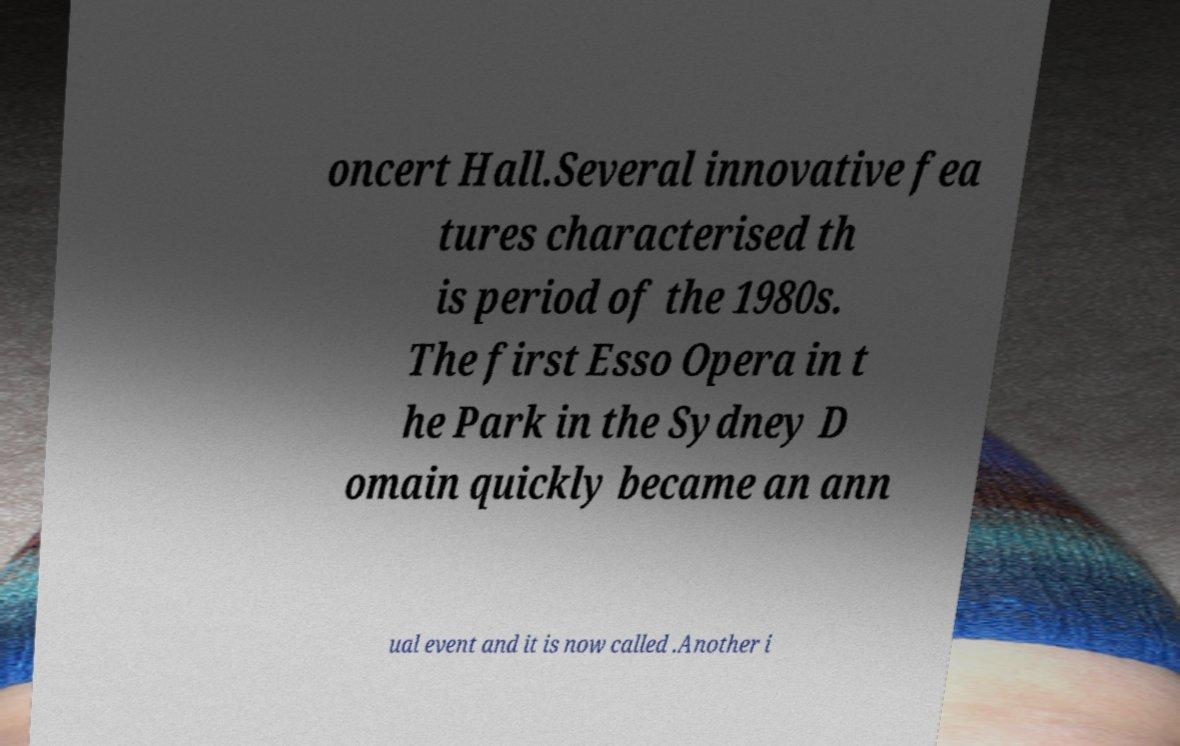What messages or text are displayed in this image? I need them in a readable, typed format. oncert Hall.Several innovative fea tures characterised th is period of the 1980s. The first Esso Opera in t he Park in the Sydney D omain quickly became an ann ual event and it is now called .Another i 